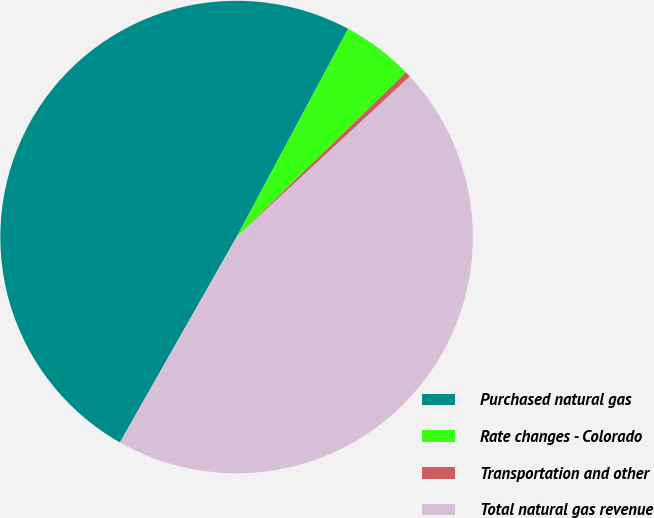<chart> <loc_0><loc_0><loc_500><loc_500><pie_chart><fcel>Purchased natural gas<fcel>Rate changes - Colorado<fcel>Transportation and other<fcel>Total natural gas revenue<nl><fcel>49.61%<fcel>4.89%<fcel>0.39%<fcel>45.11%<nl></chart> 